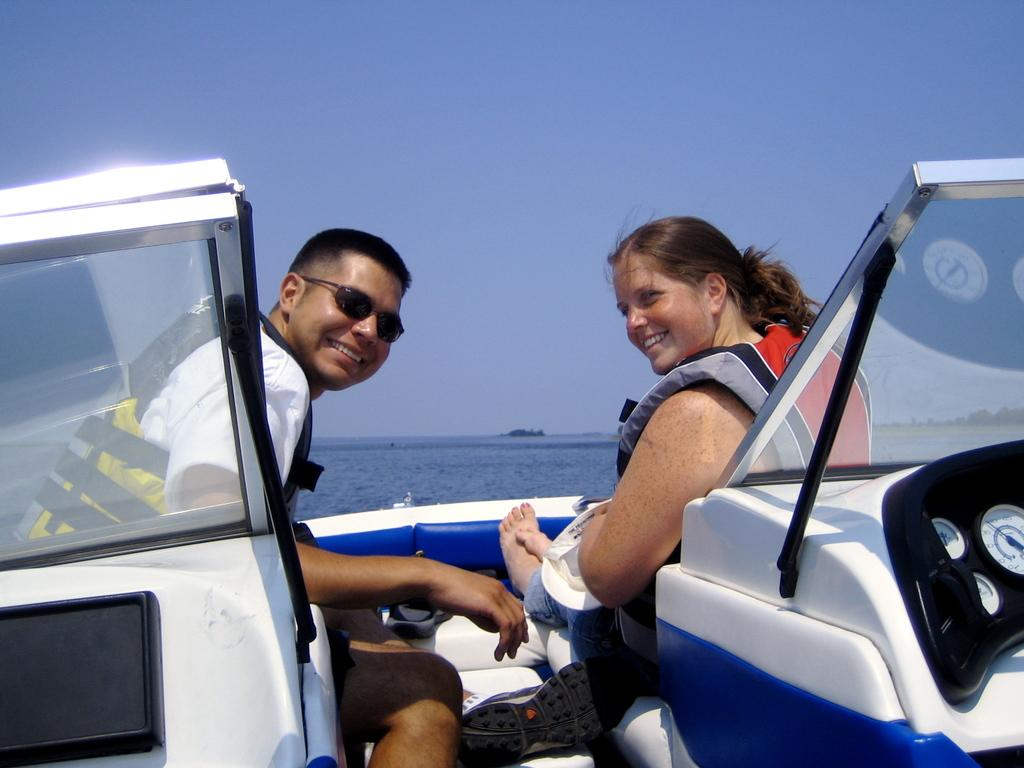How many people are in the image? There are two people in the image. What are the people doing in the image? The people are sitting in a boat. What can be seen in the background of the image? There is water visible in the background of the image. What color is the sky in the image? The sky is blue in the image. What type of rhythm can be heard coming from the chairs in the image? There are no chairs present in the image, and therefore no rhythm can be heard from them. 